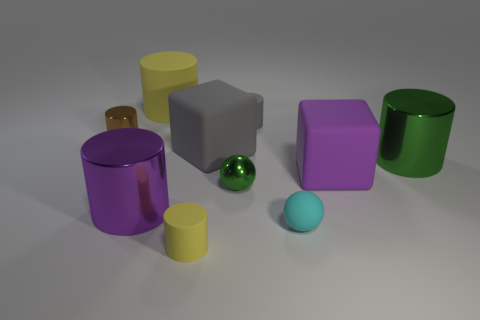There is a small matte cylinder that is on the right side of the small yellow cylinder; does it have the same color as the tiny metal object behind the gray cube? no 